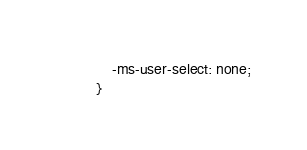<code> <loc_0><loc_0><loc_500><loc_500><_CSS_>	-ms-user-select: none;
}</code> 